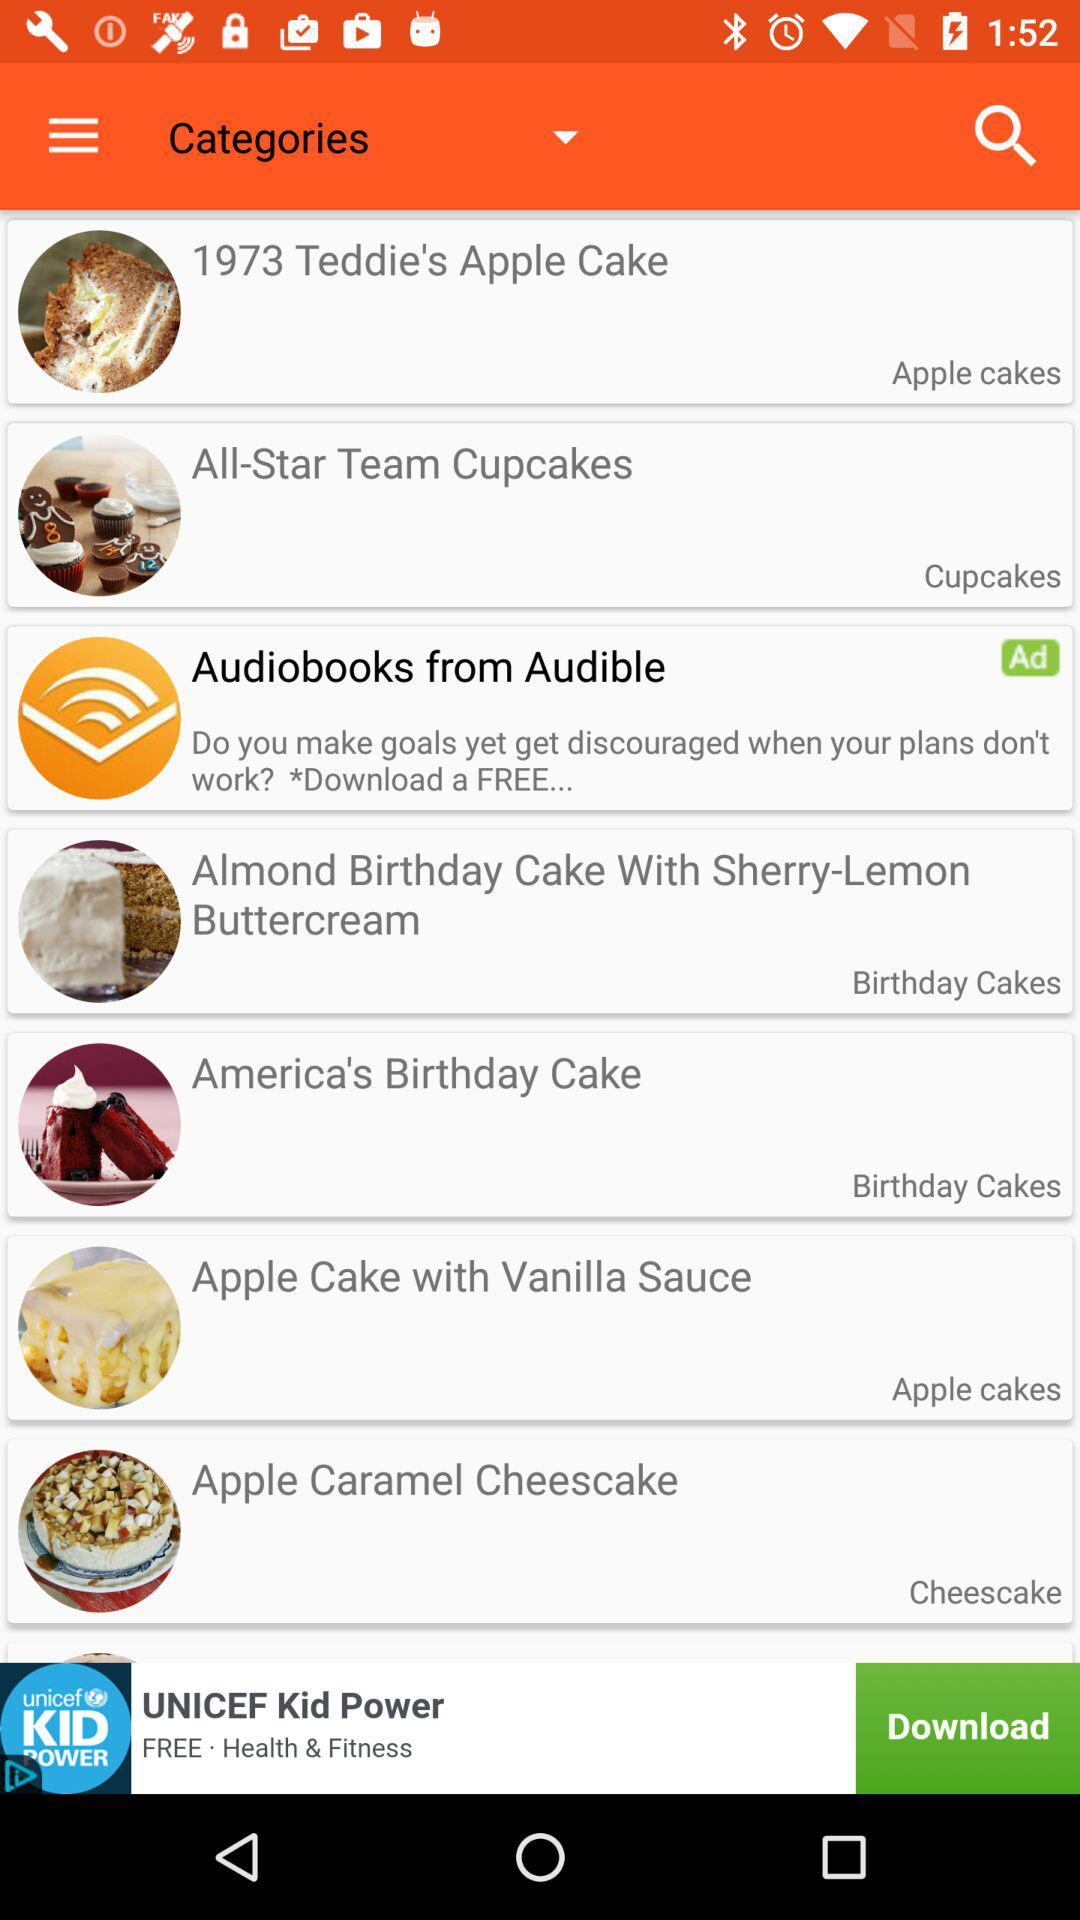Apple cake with vanilla sauce store sells which cakes?
When the provided information is insufficient, respond with <no answer>. <no answer> 